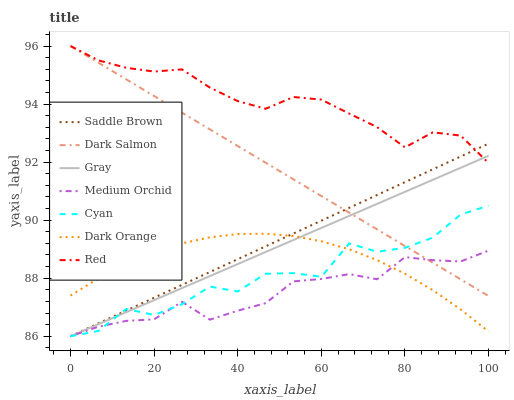Does Gray have the minimum area under the curve?
Answer yes or no. No. Does Gray have the maximum area under the curve?
Answer yes or no. No. Is Gray the smoothest?
Answer yes or no. No. Is Gray the roughest?
Answer yes or no. No. Does Dark Salmon have the lowest value?
Answer yes or no. No. Does Gray have the highest value?
Answer yes or no. No. Is Cyan less than Red?
Answer yes or no. Yes. Is Red greater than Dark Orange?
Answer yes or no. Yes. Does Cyan intersect Red?
Answer yes or no. No. 